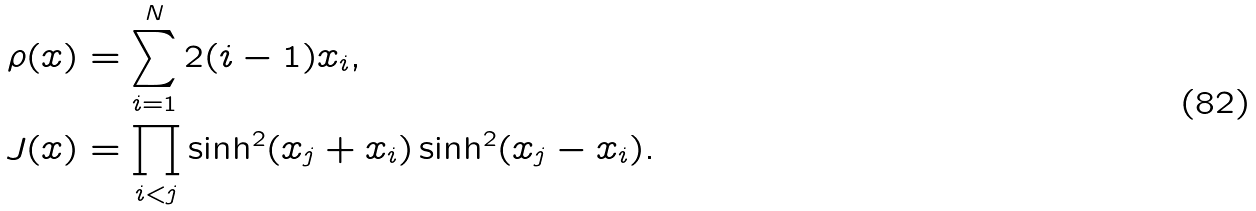Convert formula to latex. <formula><loc_0><loc_0><loc_500><loc_500>\rho ( x ) & = \sum _ { i = 1 } ^ { N } 2 ( i - 1 ) x _ { i } , \\ J ( x ) & = \prod _ { i < j } \sinh ^ { 2 } ( x _ { j } + x _ { i } ) \sinh ^ { 2 } ( x _ { j } - x _ { i } ) .</formula> 